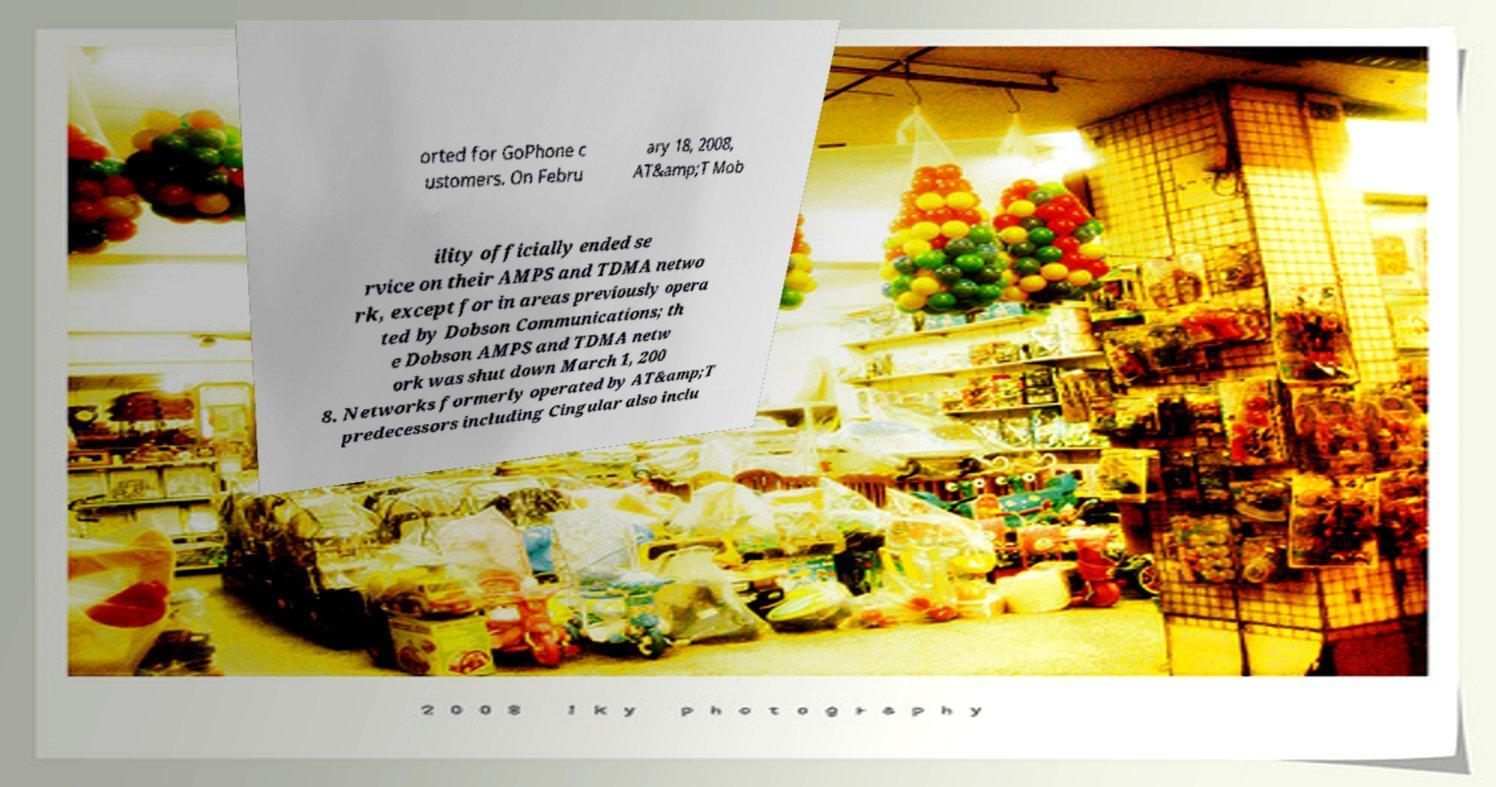Could you extract and type out the text from this image? orted for GoPhone c ustomers. On Febru ary 18, 2008, AT&amp;T Mob ility officially ended se rvice on their AMPS and TDMA netwo rk, except for in areas previously opera ted by Dobson Communications; th e Dobson AMPS and TDMA netw ork was shut down March 1, 200 8. Networks formerly operated by AT&amp;T predecessors including Cingular also inclu 